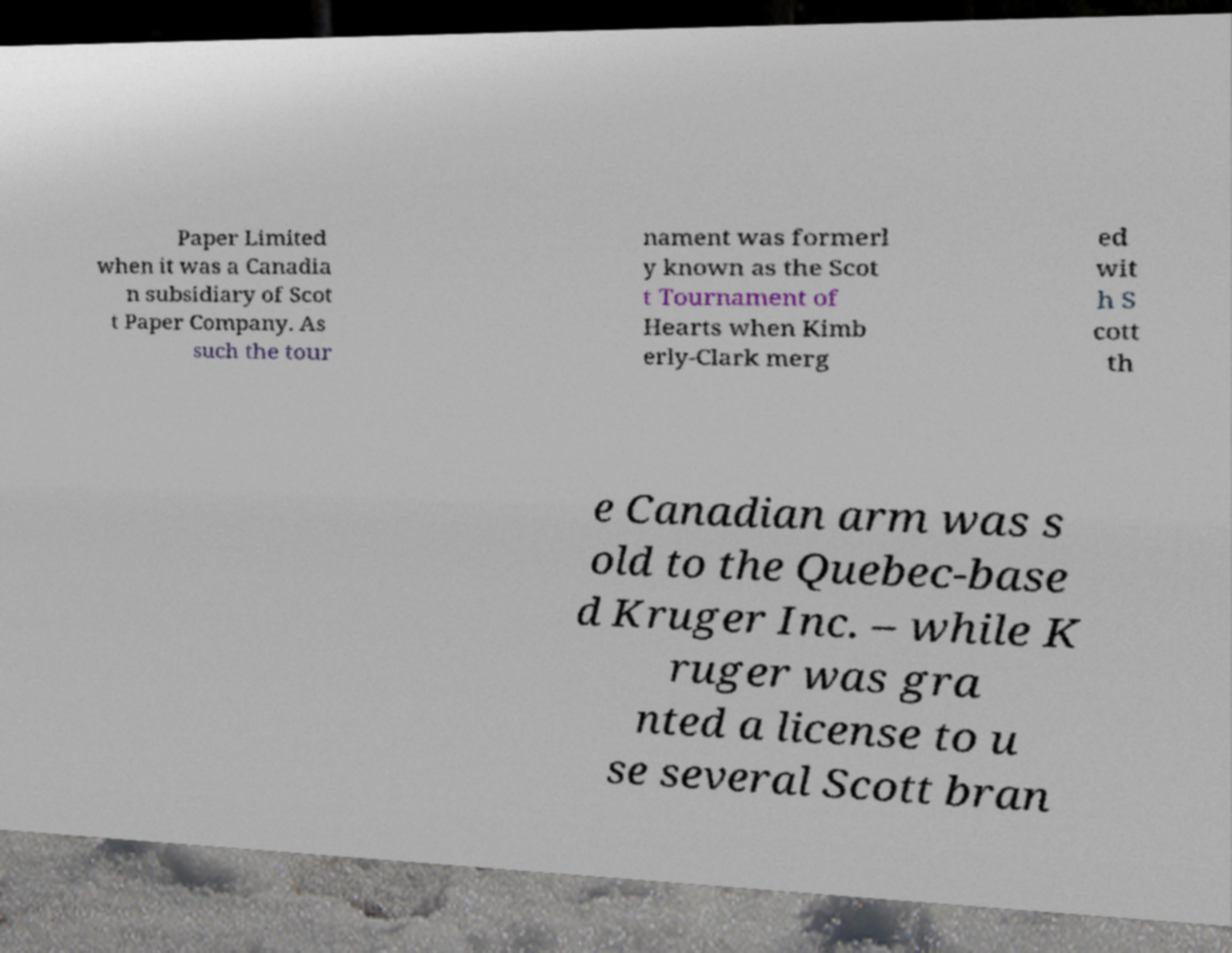Could you extract and type out the text from this image? Paper Limited when it was a Canadia n subsidiary of Scot t Paper Company. As such the tour nament was formerl y known as the Scot t Tournament of Hearts when Kimb erly-Clark merg ed wit h S cott th e Canadian arm was s old to the Quebec-base d Kruger Inc. – while K ruger was gra nted a license to u se several Scott bran 